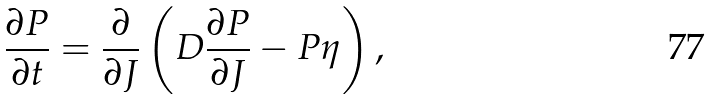Convert formula to latex. <formula><loc_0><loc_0><loc_500><loc_500>\frac { \partial P } { \partial t } = \frac { \partial } { \partial J } \left ( D \frac { \partial P } { \partial J } - P \eta \right ) ,</formula> 